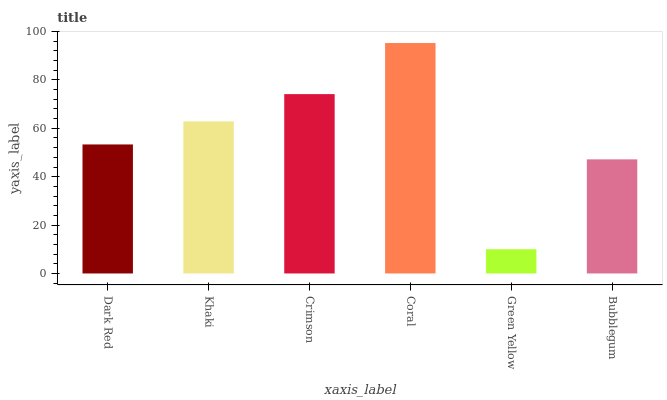Is Green Yellow the minimum?
Answer yes or no. Yes. Is Coral the maximum?
Answer yes or no. Yes. Is Khaki the minimum?
Answer yes or no. No. Is Khaki the maximum?
Answer yes or no. No. Is Khaki greater than Dark Red?
Answer yes or no. Yes. Is Dark Red less than Khaki?
Answer yes or no. Yes. Is Dark Red greater than Khaki?
Answer yes or no. No. Is Khaki less than Dark Red?
Answer yes or no. No. Is Khaki the high median?
Answer yes or no. Yes. Is Dark Red the low median?
Answer yes or no. Yes. Is Dark Red the high median?
Answer yes or no. No. Is Coral the low median?
Answer yes or no. No. 